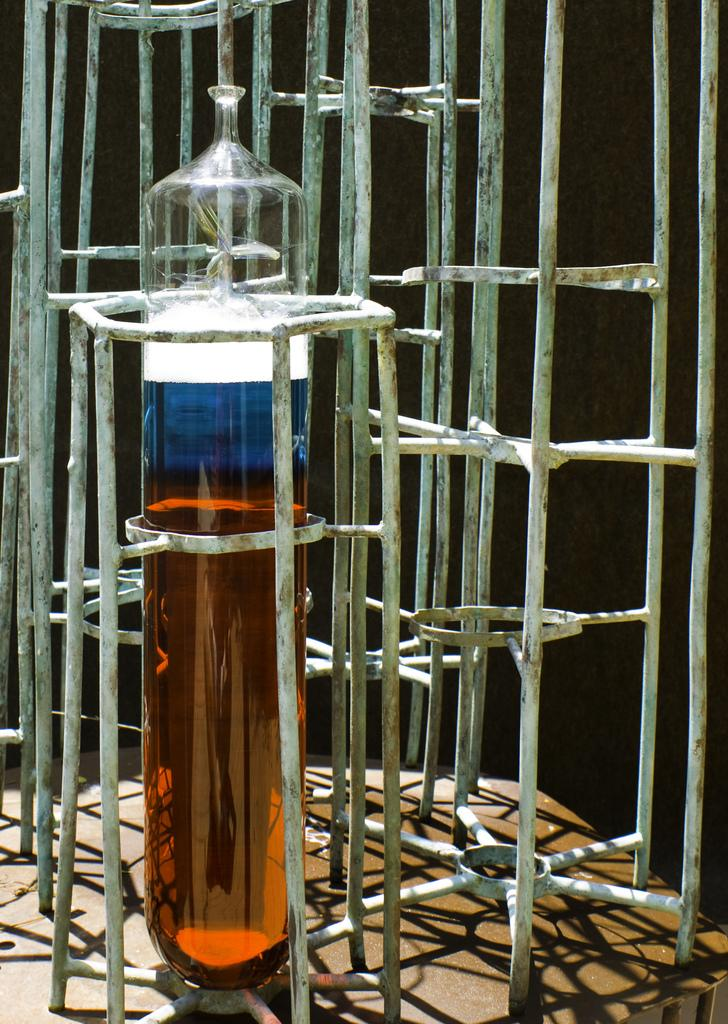What object in the image is used for climbing or reaching higher places? There is a ladder in the image that is used for climbing or reaching higher places. What object in the image contains a liquid? There is a glass containing liquid in the image. What type of education does the father in the image have? There is no father present in the image, so it is not possible to determine his level of education. What book is the person in the image reading? There is no person reading a book in the image. 